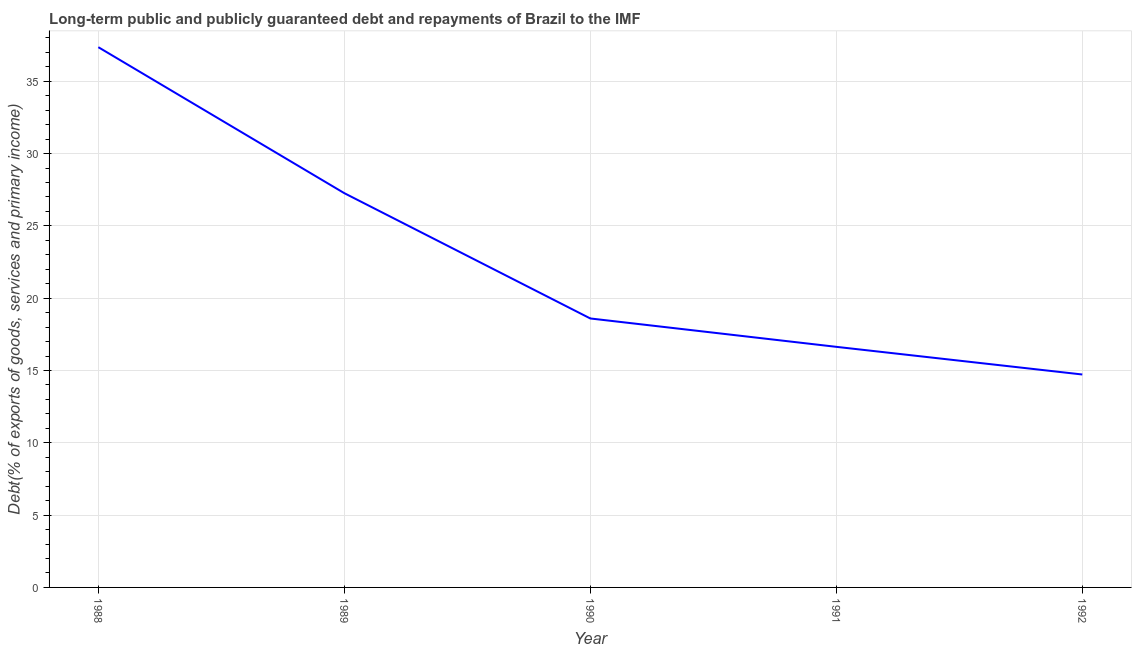What is the debt service in 1988?
Your answer should be compact. 37.36. Across all years, what is the maximum debt service?
Ensure brevity in your answer.  37.36. Across all years, what is the minimum debt service?
Your answer should be compact. 14.72. In which year was the debt service maximum?
Offer a very short reply. 1988. What is the sum of the debt service?
Your answer should be compact. 114.57. What is the difference between the debt service in 1988 and 1992?
Keep it short and to the point. 22.63. What is the average debt service per year?
Give a very brief answer. 22.91. What is the median debt service?
Keep it short and to the point. 18.6. In how many years, is the debt service greater than 6 %?
Ensure brevity in your answer.  5. Do a majority of the years between 1990 and 1988 (inclusive) have debt service greater than 7 %?
Provide a short and direct response. No. What is the ratio of the debt service in 1989 to that in 1991?
Ensure brevity in your answer.  1.64. Is the difference between the debt service in 1989 and 1992 greater than the difference between any two years?
Offer a very short reply. No. What is the difference between the highest and the second highest debt service?
Your answer should be compact. 10.09. What is the difference between the highest and the lowest debt service?
Your answer should be compact. 22.63. In how many years, is the debt service greater than the average debt service taken over all years?
Offer a terse response. 2. What is the difference between two consecutive major ticks on the Y-axis?
Offer a terse response. 5. What is the title of the graph?
Provide a short and direct response. Long-term public and publicly guaranteed debt and repayments of Brazil to the IMF. What is the label or title of the X-axis?
Your response must be concise. Year. What is the label or title of the Y-axis?
Offer a very short reply. Debt(% of exports of goods, services and primary income). What is the Debt(% of exports of goods, services and primary income) of 1988?
Your answer should be very brief. 37.36. What is the Debt(% of exports of goods, services and primary income) of 1989?
Your answer should be very brief. 27.26. What is the Debt(% of exports of goods, services and primary income) of 1990?
Keep it short and to the point. 18.6. What is the Debt(% of exports of goods, services and primary income) in 1991?
Your answer should be very brief. 16.64. What is the Debt(% of exports of goods, services and primary income) in 1992?
Provide a short and direct response. 14.72. What is the difference between the Debt(% of exports of goods, services and primary income) in 1988 and 1989?
Give a very brief answer. 10.09. What is the difference between the Debt(% of exports of goods, services and primary income) in 1988 and 1990?
Keep it short and to the point. 18.76. What is the difference between the Debt(% of exports of goods, services and primary income) in 1988 and 1991?
Keep it short and to the point. 20.72. What is the difference between the Debt(% of exports of goods, services and primary income) in 1988 and 1992?
Provide a succinct answer. 22.63. What is the difference between the Debt(% of exports of goods, services and primary income) in 1989 and 1990?
Your answer should be very brief. 8.66. What is the difference between the Debt(% of exports of goods, services and primary income) in 1989 and 1991?
Your response must be concise. 10.62. What is the difference between the Debt(% of exports of goods, services and primary income) in 1989 and 1992?
Provide a succinct answer. 12.54. What is the difference between the Debt(% of exports of goods, services and primary income) in 1990 and 1991?
Offer a very short reply. 1.96. What is the difference between the Debt(% of exports of goods, services and primary income) in 1990 and 1992?
Ensure brevity in your answer.  3.87. What is the difference between the Debt(% of exports of goods, services and primary income) in 1991 and 1992?
Offer a very short reply. 1.91. What is the ratio of the Debt(% of exports of goods, services and primary income) in 1988 to that in 1989?
Keep it short and to the point. 1.37. What is the ratio of the Debt(% of exports of goods, services and primary income) in 1988 to that in 1990?
Provide a succinct answer. 2.01. What is the ratio of the Debt(% of exports of goods, services and primary income) in 1988 to that in 1991?
Make the answer very short. 2.25. What is the ratio of the Debt(% of exports of goods, services and primary income) in 1988 to that in 1992?
Keep it short and to the point. 2.54. What is the ratio of the Debt(% of exports of goods, services and primary income) in 1989 to that in 1990?
Offer a very short reply. 1.47. What is the ratio of the Debt(% of exports of goods, services and primary income) in 1989 to that in 1991?
Give a very brief answer. 1.64. What is the ratio of the Debt(% of exports of goods, services and primary income) in 1989 to that in 1992?
Provide a succinct answer. 1.85. What is the ratio of the Debt(% of exports of goods, services and primary income) in 1990 to that in 1991?
Your response must be concise. 1.12. What is the ratio of the Debt(% of exports of goods, services and primary income) in 1990 to that in 1992?
Make the answer very short. 1.26. What is the ratio of the Debt(% of exports of goods, services and primary income) in 1991 to that in 1992?
Make the answer very short. 1.13. 